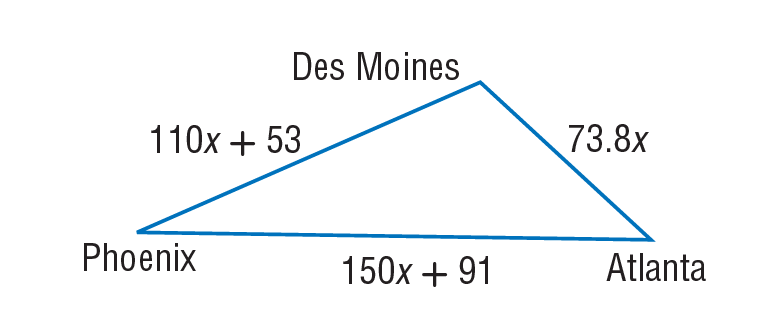Question: A plane travels from Des Moines to Phoenix, on to Atlanta, and back to Des Moines, as shown below. Find the distance in miles from Des Moines to Phoenix if the total trip was 3482 miles.
Choices:
A. 73.8
B. 91
C. 110
D. 1153
Answer with the letter. Answer: D Question: A plane travels from Des Moines to Phoenix, on to Atlanta, and back to Des Moines, as shown below. Find the distance in miles from Atlanta to Des Moines if the total trip was 3482 miles.
Choices:
A. 73.8
B. 110
C. 150
D. 738
Answer with the letter. Answer: D 